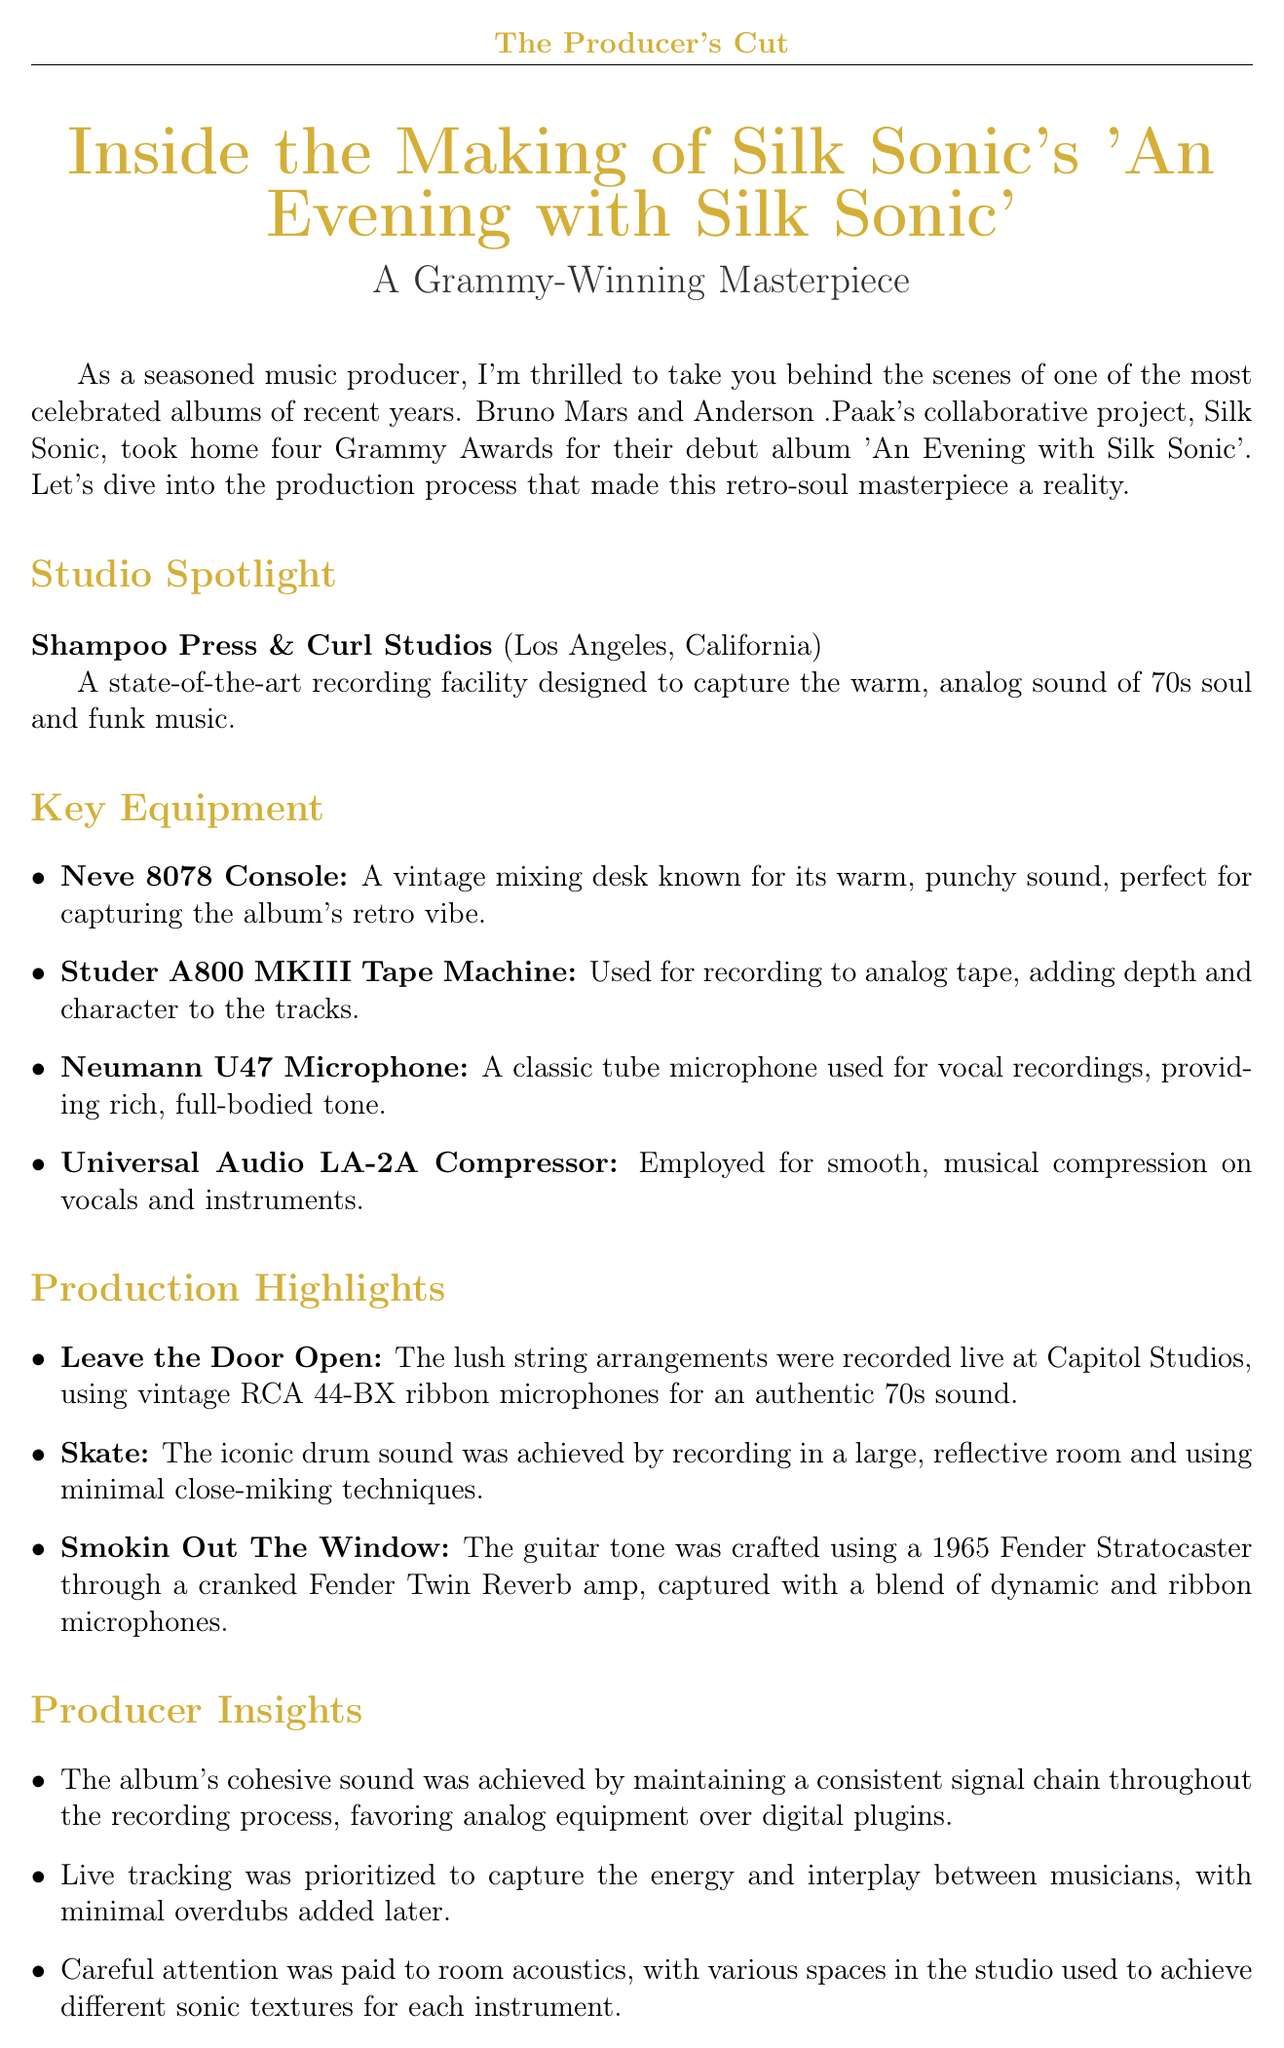What is the title of the album? The title of the album is explicitly mentioned in the newsletter as 'An Evening with Silk Sonic'.
Answer: An Evening with Silk Sonic How many Grammy Awards did Silk Sonic win? The document states that Silk Sonic took home four Grammy Awards for their debut album.
Answer: Four What type of studio is Shampoo Press & Curl Studios? The newsletter describes it as a state-of-the-art recording facility.
Answer: State-of-the-art recording facility Which microphone is used for vocal recordings? The Neumann U47 Microphone is specifically mentioned as a classic tube microphone used for vocal recordings.
Answer: Neumann U47 Microphone What track features lush string arrangements recorded live? The track 'Leave the Door Open' includes this detail about lush string arrangements recorded at Capitol Studios.
Answer: Leave the Door Open What was a key focus in the recording process? The priority on live tracking to capture the energy and interplay between musicians is highlighted as a key focus.
Answer: Live tracking What year was the 1965 Fender Stratocaster used? The newsletter mentions the guitar tone crafted using a 1965 Fender Stratocaster.
Answer: 1965 Where were the string arrangements recorded? The document notes that the lush string arrangements were recorded live at Capitol Studios.
Answer: Capitol Studios 